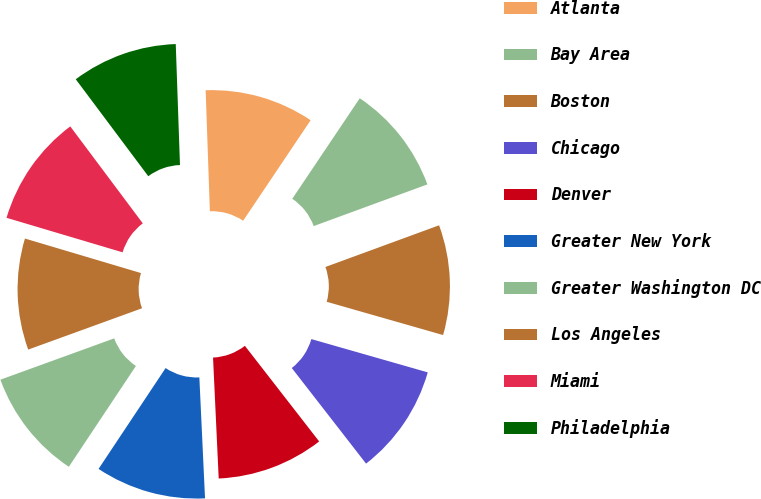Convert chart. <chart><loc_0><loc_0><loc_500><loc_500><pie_chart><fcel>Atlanta<fcel>Bay Area<fcel>Boston<fcel>Chicago<fcel>Denver<fcel>Greater New York<fcel>Greater Washington DC<fcel>Los Angeles<fcel>Miami<fcel>Philadelphia<nl><fcel>9.97%<fcel>10.0%<fcel>10.03%<fcel>10.06%<fcel>9.77%<fcel>10.09%<fcel>10.12%<fcel>10.15%<fcel>10.18%<fcel>9.67%<nl></chart> 